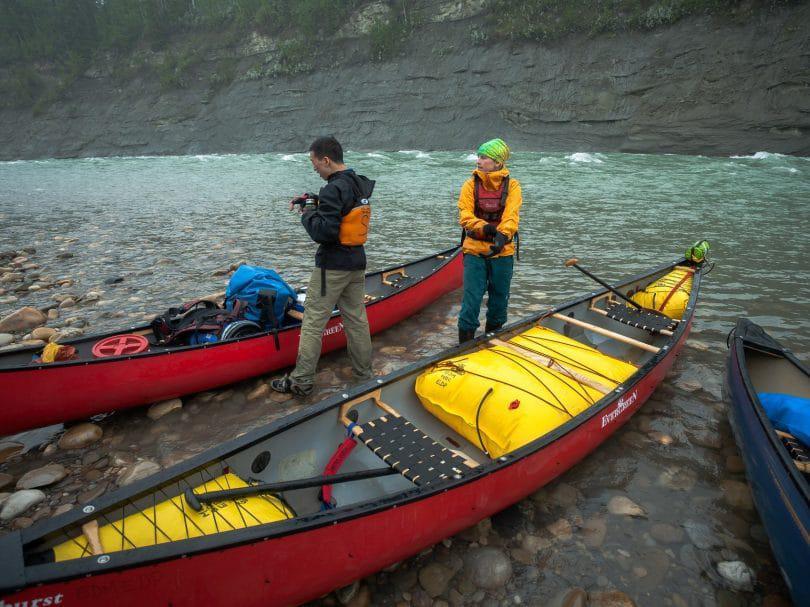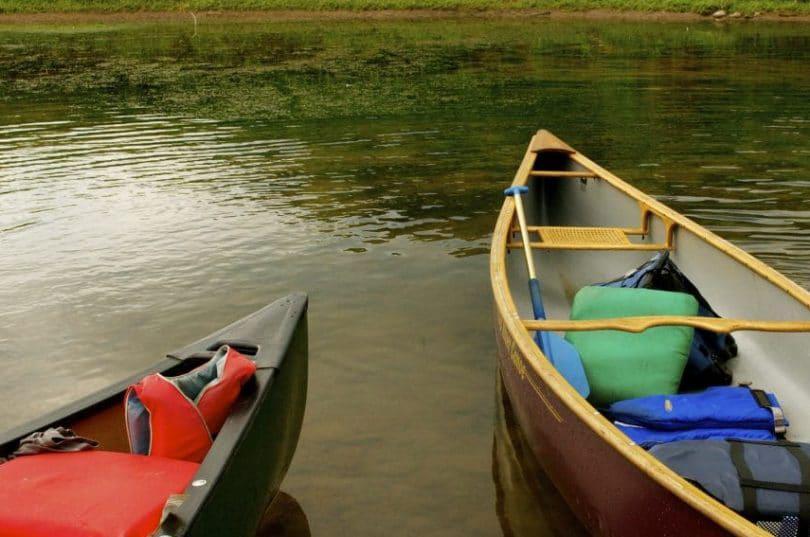The first image is the image on the left, the second image is the image on the right. Examine the images to the left and right. Is the description "At least one person is standing on the shore in the image on the right." accurate? Answer yes or no. No. The first image is the image on the left, the second image is the image on the right. Analyze the images presented: Is the assertion "An image includes a canoe with multiple riders afloat on the water." valid? Answer yes or no. No. 